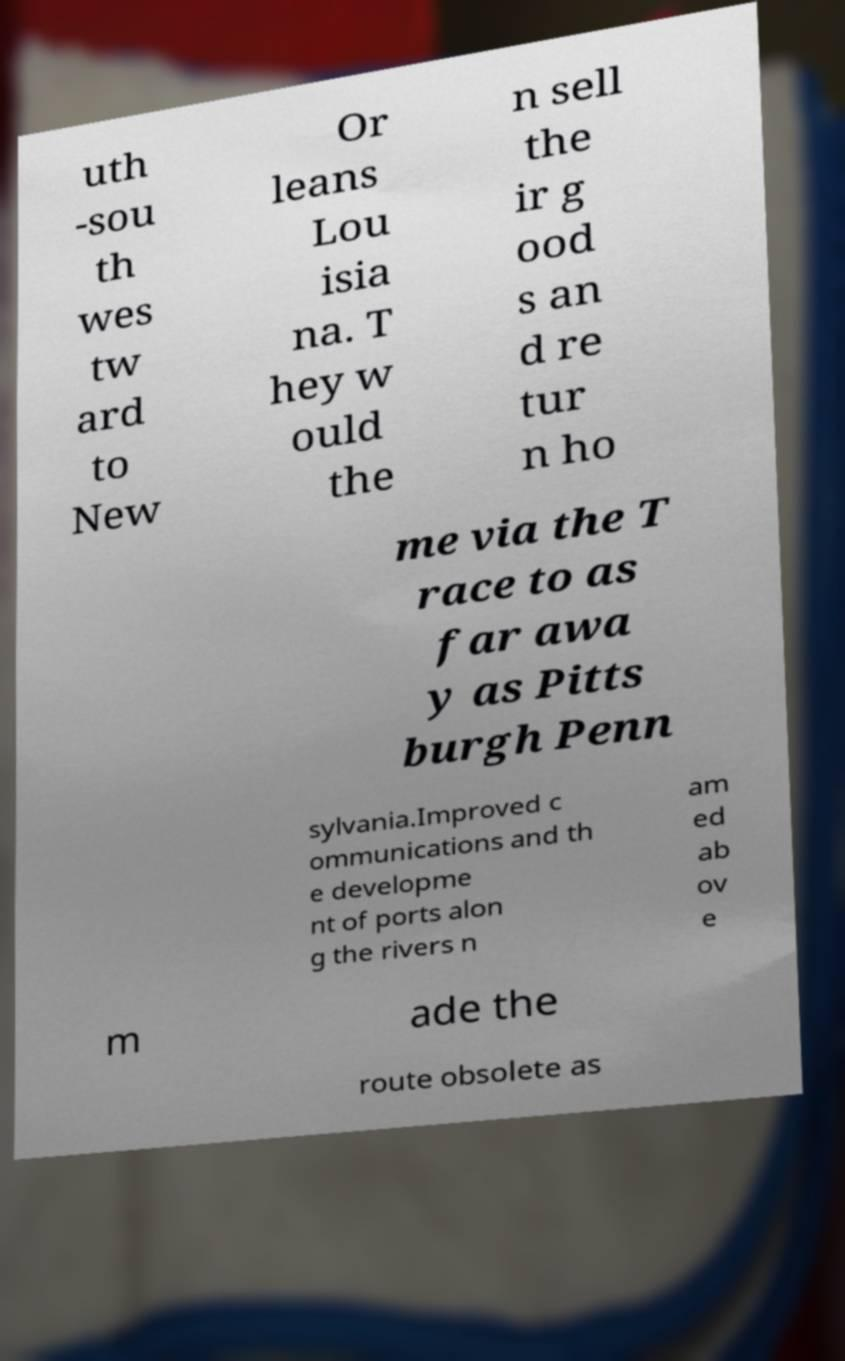For documentation purposes, I need the text within this image transcribed. Could you provide that? uth -sou th wes tw ard to New Or leans Lou isia na. T hey w ould the n sell the ir g ood s an d re tur n ho me via the T race to as far awa y as Pitts burgh Penn sylvania.Improved c ommunications and th e developme nt of ports alon g the rivers n am ed ab ov e m ade the route obsolete as 